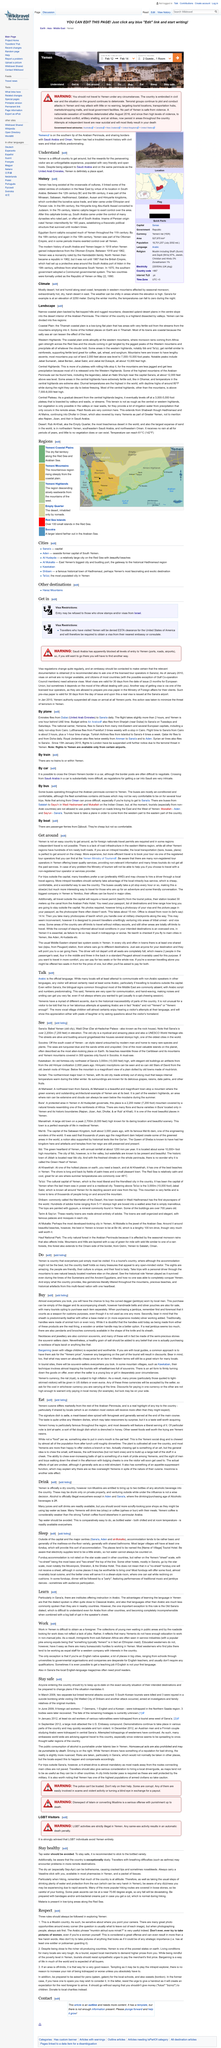Mention a couple of crucial points in this snapshot. It is advisable to avoid scruffy-looking juice shops that use tap water as their primary base. Yes, there is an exception to the rule that work in Yemen is difficult to obtain as a foreigner. According to the article "Talk," any visitor to Yemen, regardless of the location, will require some knowledge of Arabic in order to communicate effectively. It is permissible for non-Muslims to bring two bottles of alcohol into Yemen. Immigrants from sub-Saharan Africa are often employed in service industries. 